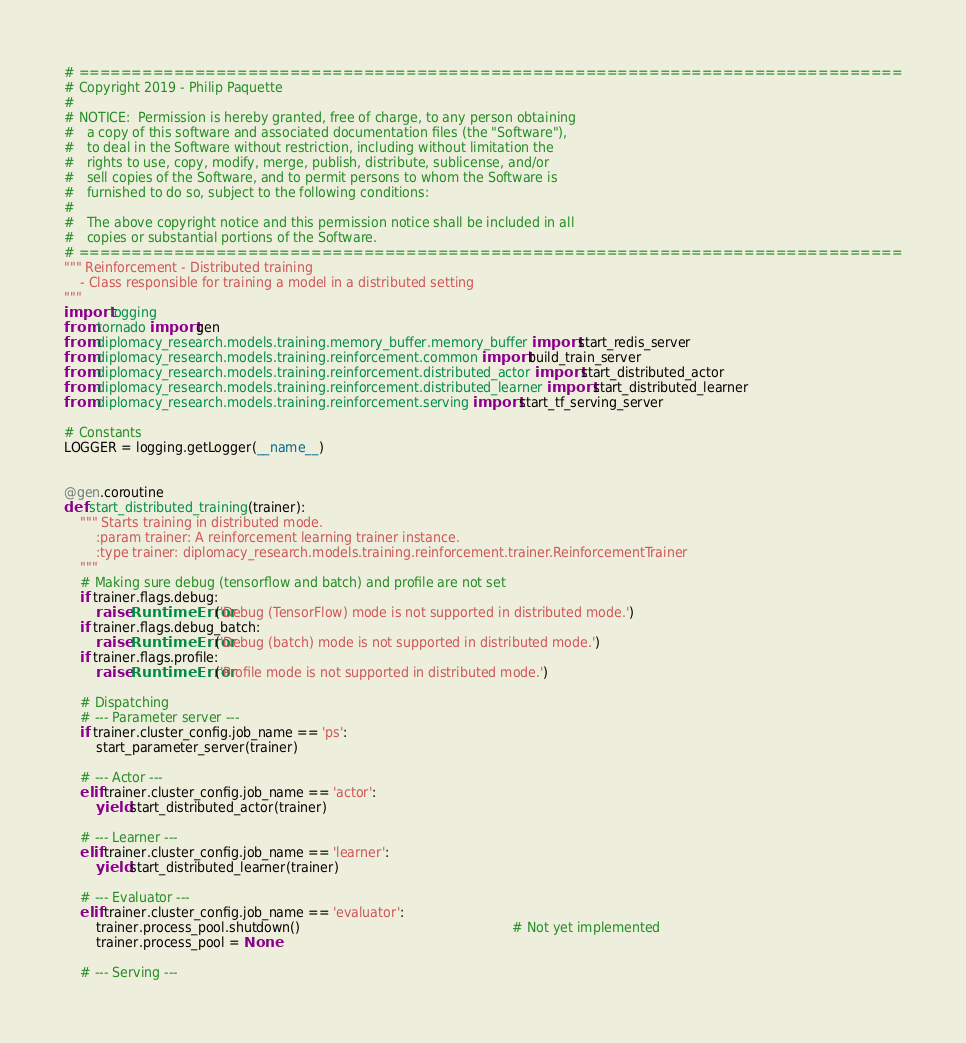Convert code to text. <code><loc_0><loc_0><loc_500><loc_500><_Python_># ==============================================================================
# Copyright 2019 - Philip Paquette
#
# NOTICE:  Permission is hereby granted, free of charge, to any person obtaining
#   a copy of this software and associated documentation files (the "Software"),
#   to deal in the Software without restriction, including without limitation the
#   rights to use, copy, modify, merge, publish, distribute, sublicense, and/or
#   sell copies of the Software, and to permit persons to whom the Software is
#   furnished to do so, subject to the following conditions:
#
#   The above copyright notice and this permission notice shall be included in all
#   copies or substantial portions of the Software.
# ==============================================================================
""" Reinforcement - Distributed training
    - Class responsible for training a model in a distributed setting
"""
import logging
from tornado import gen
from diplomacy_research.models.training.memory_buffer.memory_buffer import start_redis_server
from diplomacy_research.models.training.reinforcement.common import build_train_server
from diplomacy_research.models.training.reinforcement.distributed_actor import start_distributed_actor
from diplomacy_research.models.training.reinforcement.distributed_learner import start_distributed_learner
from diplomacy_research.models.training.reinforcement.serving import start_tf_serving_server

# Constants
LOGGER = logging.getLogger(__name__)


@gen.coroutine
def start_distributed_training(trainer):
    """ Starts training in distributed mode.
        :param trainer: A reinforcement learning trainer instance.
        :type trainer: diplomacy_research.models.training.reinforcement.trainer.ReinforcementTrainer
    """
    # Making sure debug (tensorflow and batch) and profile are not set
    if trainer.flags.debug:
        raise RuntimeError('Debug (TensorFlow) mode is not supported in distributed mode.')
    if trainer.flags.debug_batch:
        raise RuntimeError('Debug (batch) mode is not supported in distributed mode.')
    if trainer.flags.profile:
        raise RuntimeError('Profile mode is not supported in distributed mode.')

    # Dispatching
    # --- Parameter server ---
    if trainer.cluster_config.job_name == 'ps':
        start_parameter_server(trainer)

    # --- Actor ---
    elif trainer.cluster_config.job_name == 'actor':
        yield start_distributed_actor(trainer)

    # --- Learner ---
    elif trainer.cluster_config.job_name == 'learner':
        yield start_distributed_learner(trainer)

    # --- Evaluator ---
    elif trainer.cluster_config.job_name == 'evaluator':
        trainer.process_pool.shutdown()                                                     # Not yet implemented
        trainer.process_pool = None

    # --- Serving ---</code> 